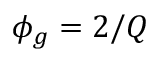<formula> <loc_0><loc_0><loc_500><loc_500>\phi _ { g } = 2 / Q</formula> 